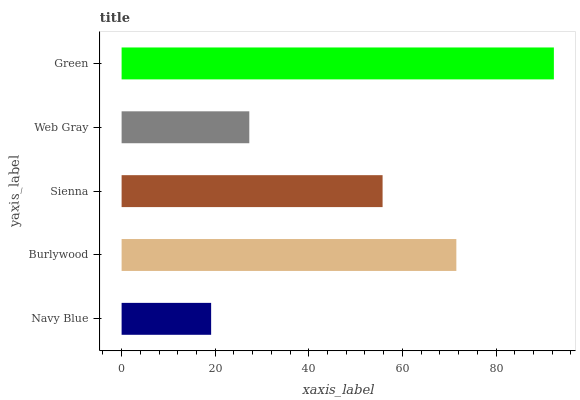Is Navy Blue the minimum?
Answer yes or no. Yes. Is Green the maximum?
Answer yes or no. Yes. Is Burlywood the minimum?
Answer yes or no. No. Is Burlywood the maximum?
Answer yes or no. No. Is Burlywood greater than Navy Blue?
Answer yes or no. Yes. Is Navy Blue less than Burlywood?
Answer yes or no. Yes. Is Navy Blue greater than Burlywood?
Answer yes or no. No. Is Burlywood less than Navy Blue?
Answer yes or no. No. Is Sienna the high median?
Answer yes or no. Yes. Is Sienna the low median?
Answer yes or no. Yes. Is Burlywood the high median?
Answer yes or no. No. Is Green the low median?
Answer yes or no. No. 